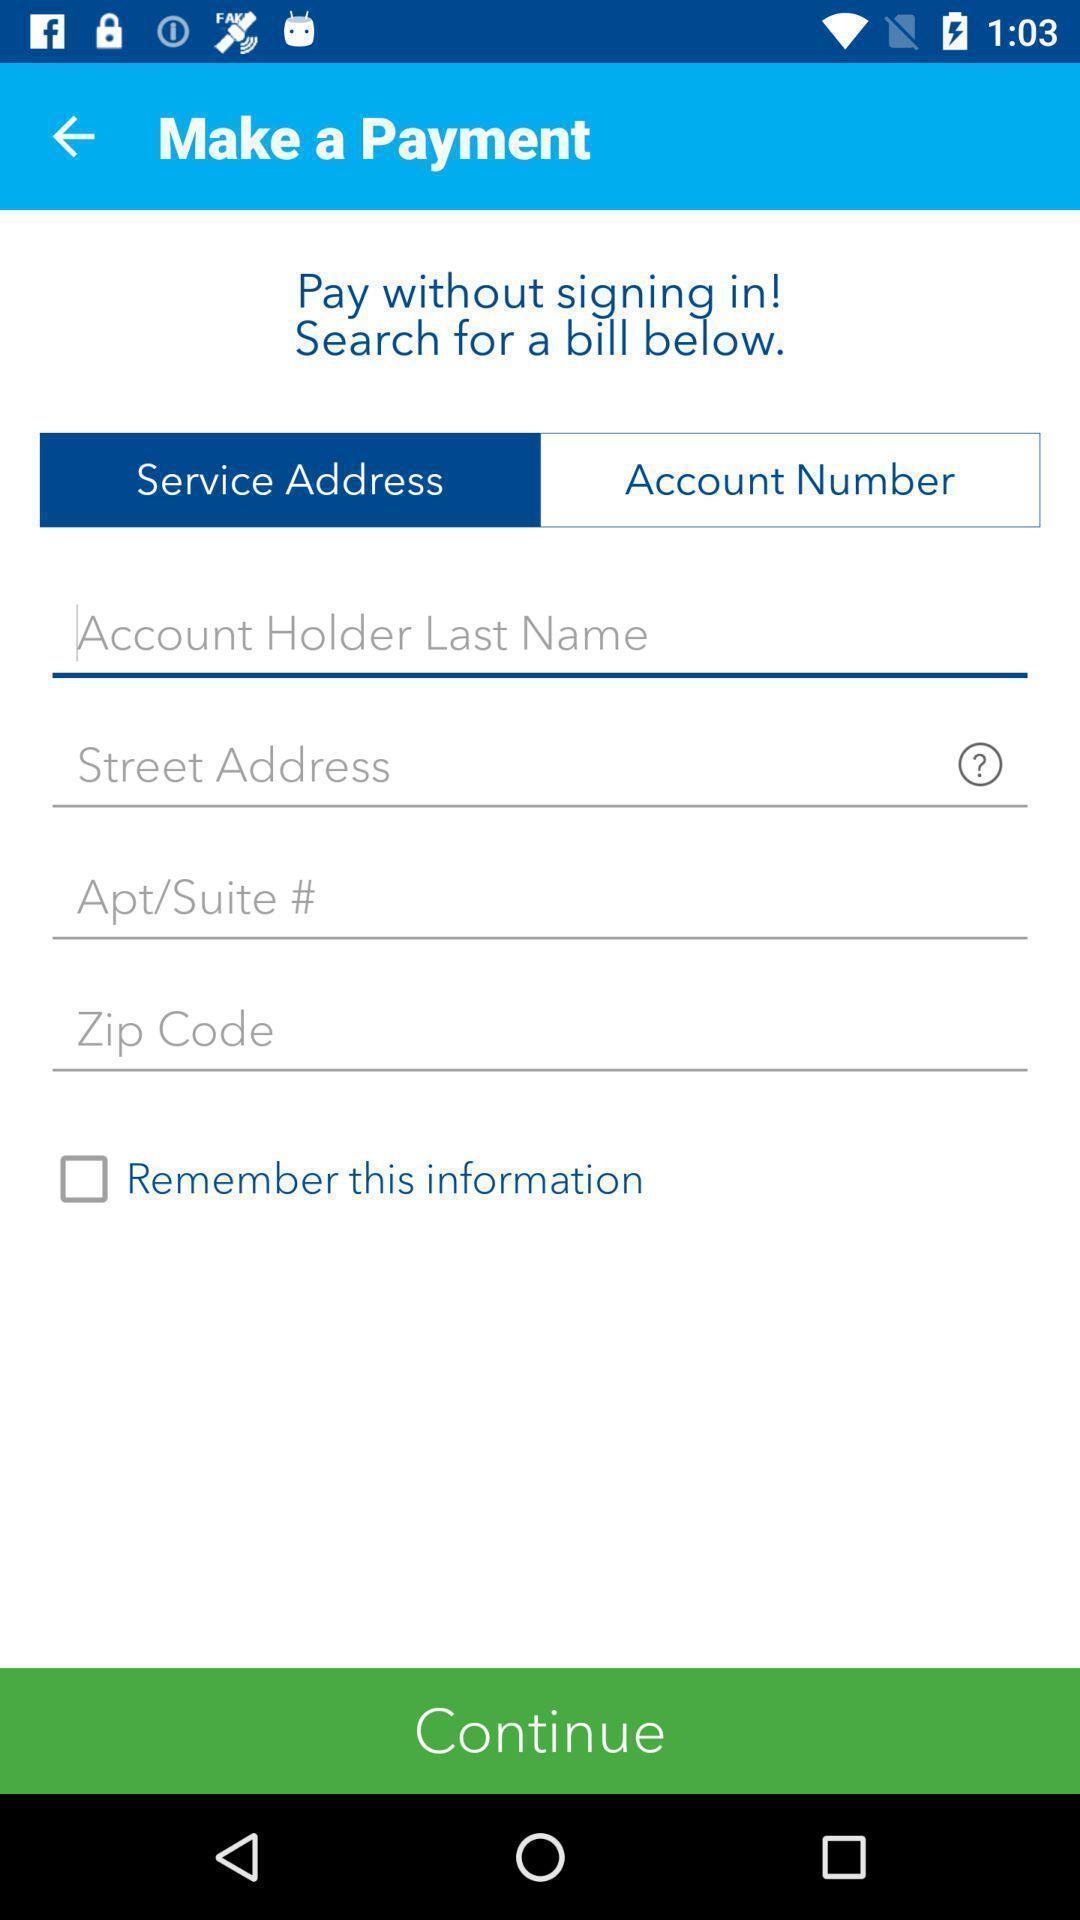Describe the content in this image. Screen showing fields to enter in an banking application. 